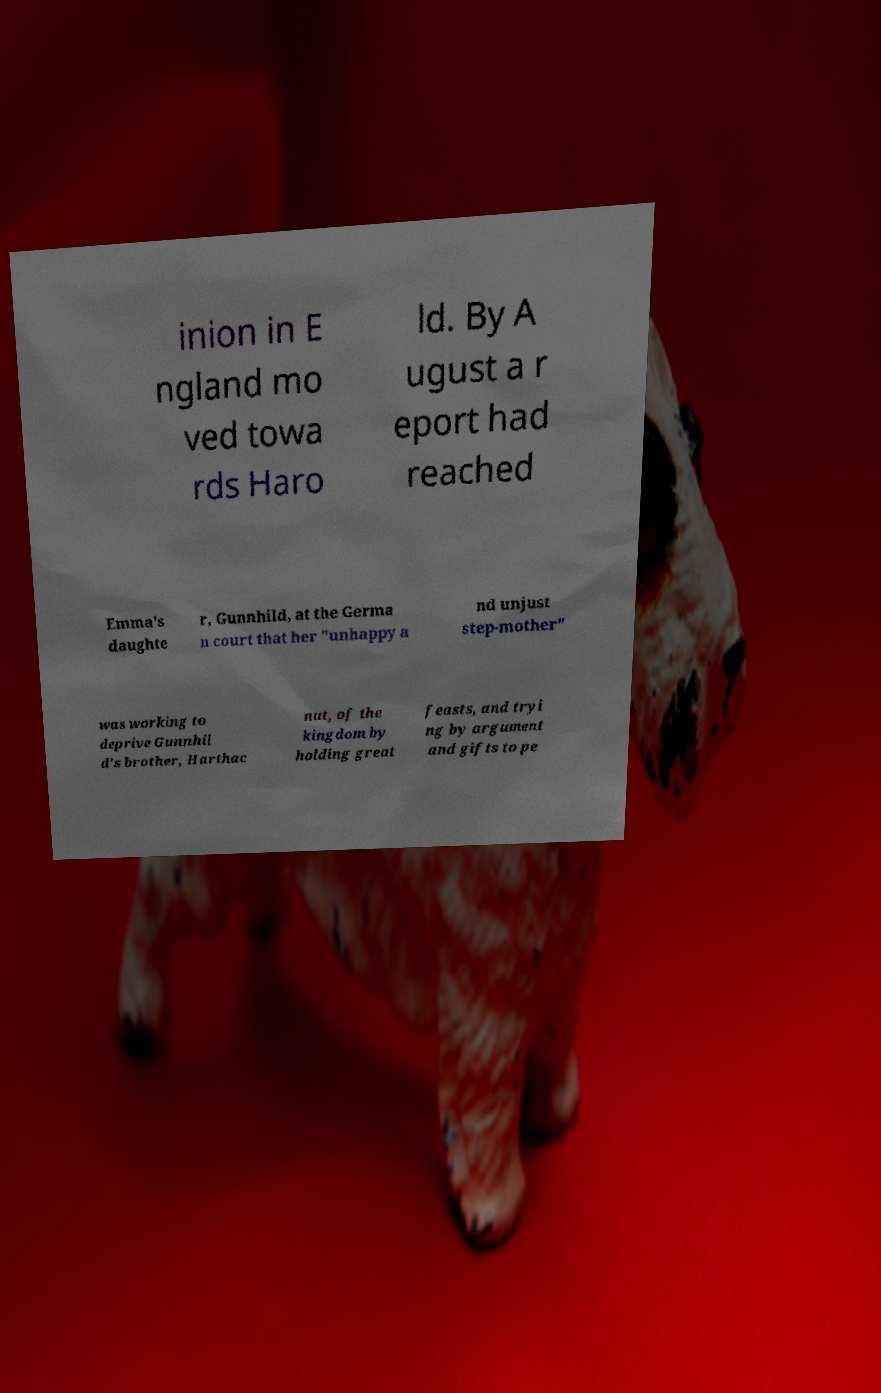There's text embedded in this image that I need extracted. Can you transcribe it verbatim? inion in E ngland mo ved towa rds Haro ld. By A ugust a r eport had reached Emma's daughte r, Gunnhild, at the Germa n court that her "unhappy a nd unjust step-mother" was working to deprive Gunnhil d's brother, Harthac nut, of the kingdom by holding great feasts, and tryi ng by argument and gifts to pe 